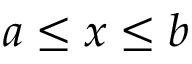<formula> <loc_0><loc_0><loc_500><loc_500>a \leq x \leq b</formula> 